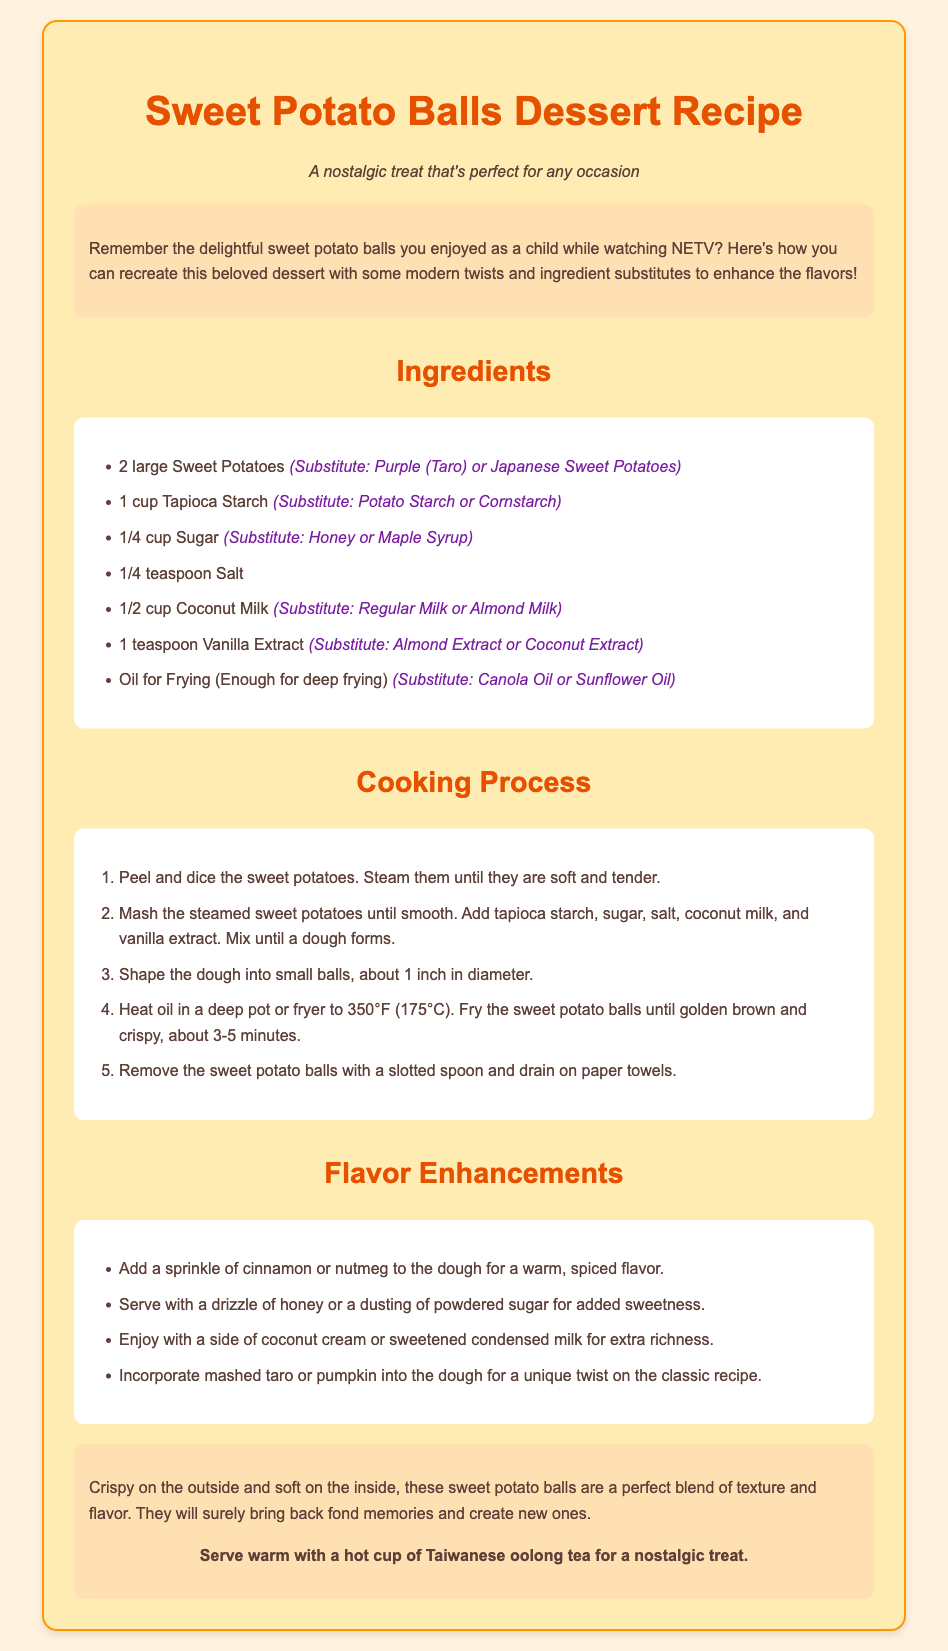What are the main ingredients for Sweet Potato Balls? The main ingredients are listed in the ingredients section of the document.
Answer: Sweet Potatoes, Tapioca Starch, Sugar, Salt, Coconut Milk, Vanilla Extract, Oil What can be used instead of Sugar? The substitutes for sugar are provided alongside the ingredient in the document.
Answer: Honey or Maple Syrup What temperature should the oil be heated to? The cooking process specifies the temperature at which the oil should be heated for frying.
Answer: 350°F (175°C) What is a suggested flavor enhancement? The flavor enhancements section lists various ways to improve the flavor of the dessert.
Answer: Sprinkle of cinnamon or nutmeg How long should the sweet potato balls be fried? The cooking process indicates the duration for frying the sweet potato balls until they are golden brown.
Answer: 3-5 minutes What is a serving suggestion mentioned in the document? The finished dish section provides a specific suggestion for serving the dessert.
Answer: Serve warm with a hot cup of Taiwanese oolong tea What type of dessert is this recipe for? The title and description indicate the type of dish this recipe is for.
Answer: Dessert What can replace Tapioca Starch? The ingredients section suggests alternatives for tapioca starch.
Answer: Potato Starch or Cornstarch 